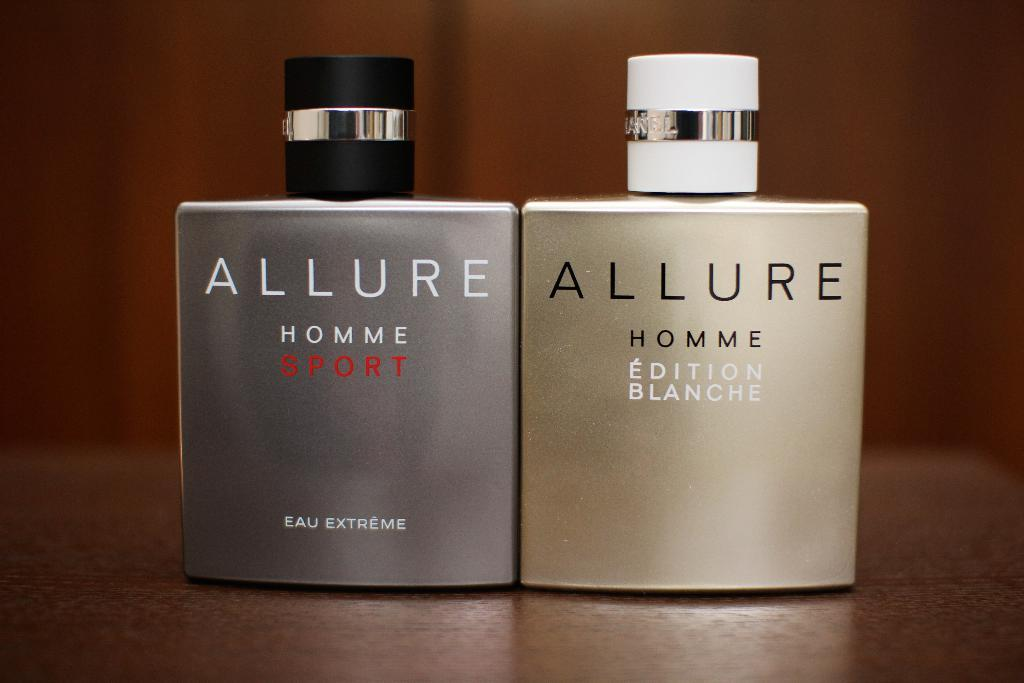Provide a one-sentence caption for the provided image. Two Allure branded containers sit on a table. 